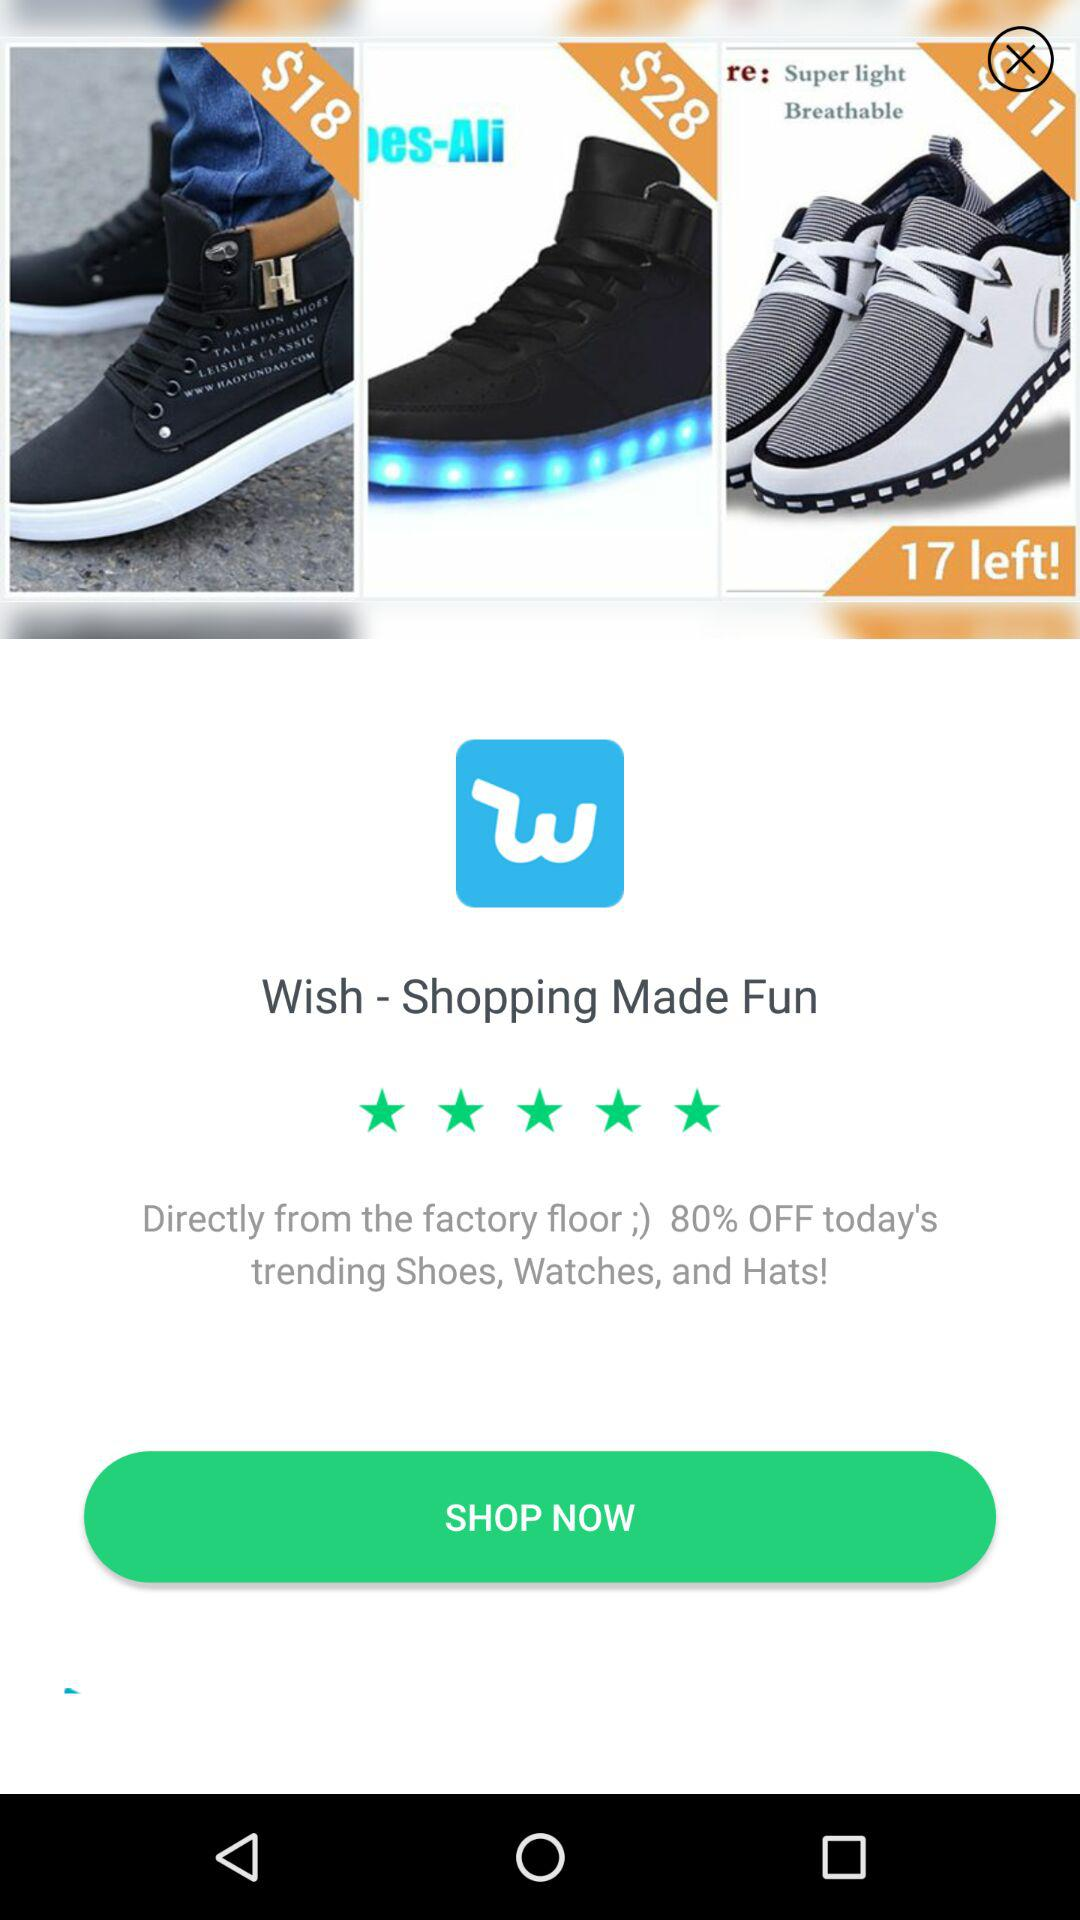How many reviews are there?
When the provided information is insufficient, respond with <no answer>. <no answer> 